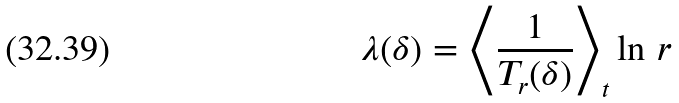Convert formula to latex. <formula><loc_0><loc_0><loc_500><loc_500>\lambda ( \delta ) = \left < \frac { 1 } { T _ { r } ( \delta ) } \right > _ { t } \ln \, r</formula> 